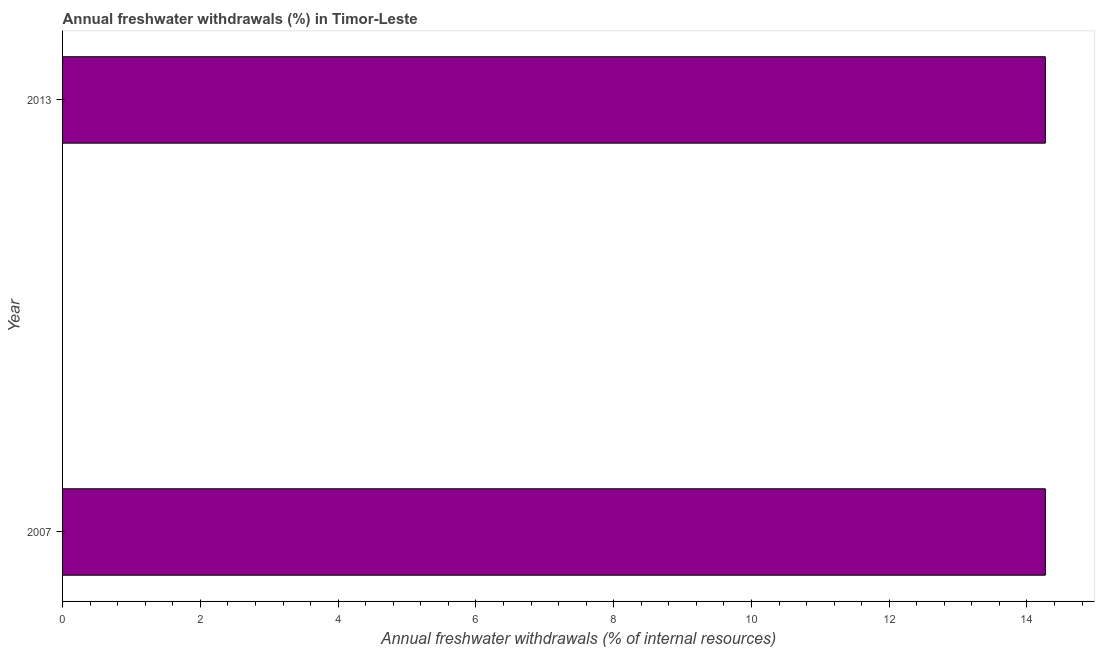What is the title of the graph?
Your response must be concise. Annual freshwater withdrawals (%) in Timor-Leste. What is the label or title of the X-axis?
Ensure brevity in your answer.  Annual freshwater withdrawals (% of internal resources). What is the label or title of the Y-axis?
Ensure brevity in your answer.  Year. What is the annual freshwater withdrawals in 2007?
Provide a succinct answer. 14.27. Across all years, what is the maximum annual freshwater withdrawals?
Make the answer very short. 14.27. Across all years, what is the minimum annual freshwater withdrawals?
Provide a succinct answer. 14.27. In which year was the annual freshwater withdrawals maximum?
Keep it short and to the point. 2007. What is the sum of the annual freshwater withdrawals?
Give a very brief answer. 28.53. What is the difference between the annual freshwater withdrawals in 2007 and 2013?
Provide a succinct answer. 0. What is the average annual freshwater withdrawals per year?
Your answer should be very brief. 14.27. What is the median annual freshwater withdrawals?
Your answer should be very brief. 14.27. In how many years, is the annual freshwater withdrawals greater than 7.2 %?
Keep it short and to the point. 2. What is the ratio of the annual freshwater withdrawals in 2007 to that in 2013?
Provide a short and direct response. 1. In how many years, is the annual freshwater withdrawals greater than the average annual freshwater withdrawals taken over all years?
Offer a very short reply. 0. Are all the bars in the graph horizontal?
Provide a short and direct response. Yes. How many years are there in the graph?
Keep it short and to the point. 2. What is the Annual freshwater withdrawals (% of internal resources) in 2007?
Offer a terse response. 14.27. What is the Annual freshwater withdrawals (% of internal resources) in 2013?
Ensure brevity in your answer.  14.27. What is the ratio of the Annual freshwater withdrawals (% of internal resources) in 2007 to that in 2013?
Make the answer very short. 1. 